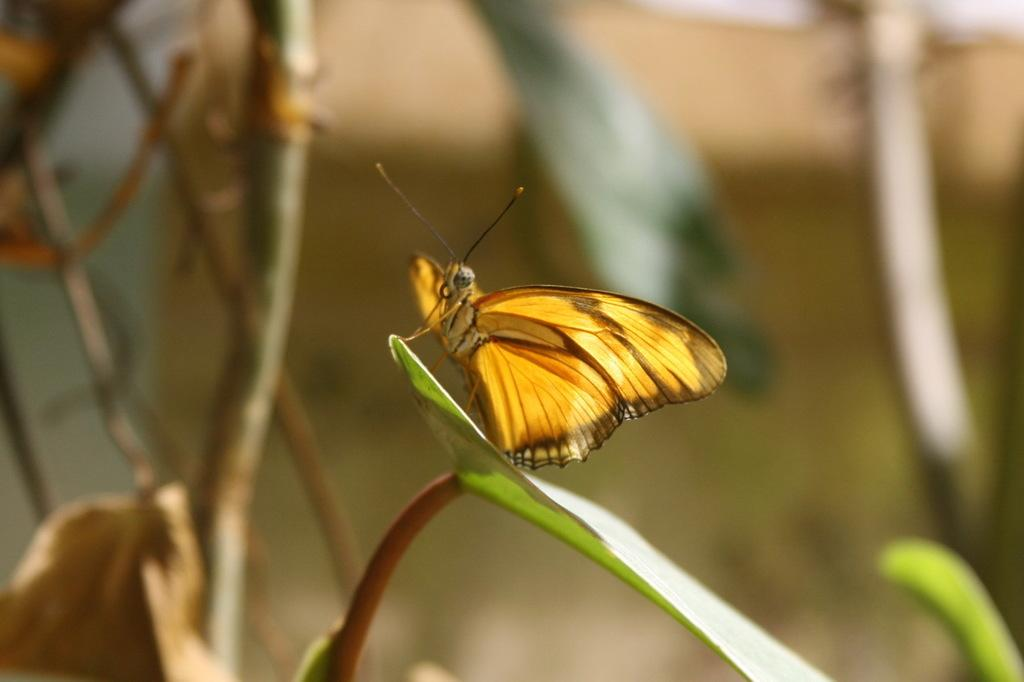What is the main subject of the image? There is a butterfly on a leaf in the image. Can you describe the butterfly's location in the image? The butterfly is on a leaf in the image. What else can be seen in the background of the image? There is a stem and leaf in the background of the image. How many oranges are hanging from the stem in the image? There are no oranges present in the image; it features a butterfly on a leaf and a stem with another leaf in the background. 